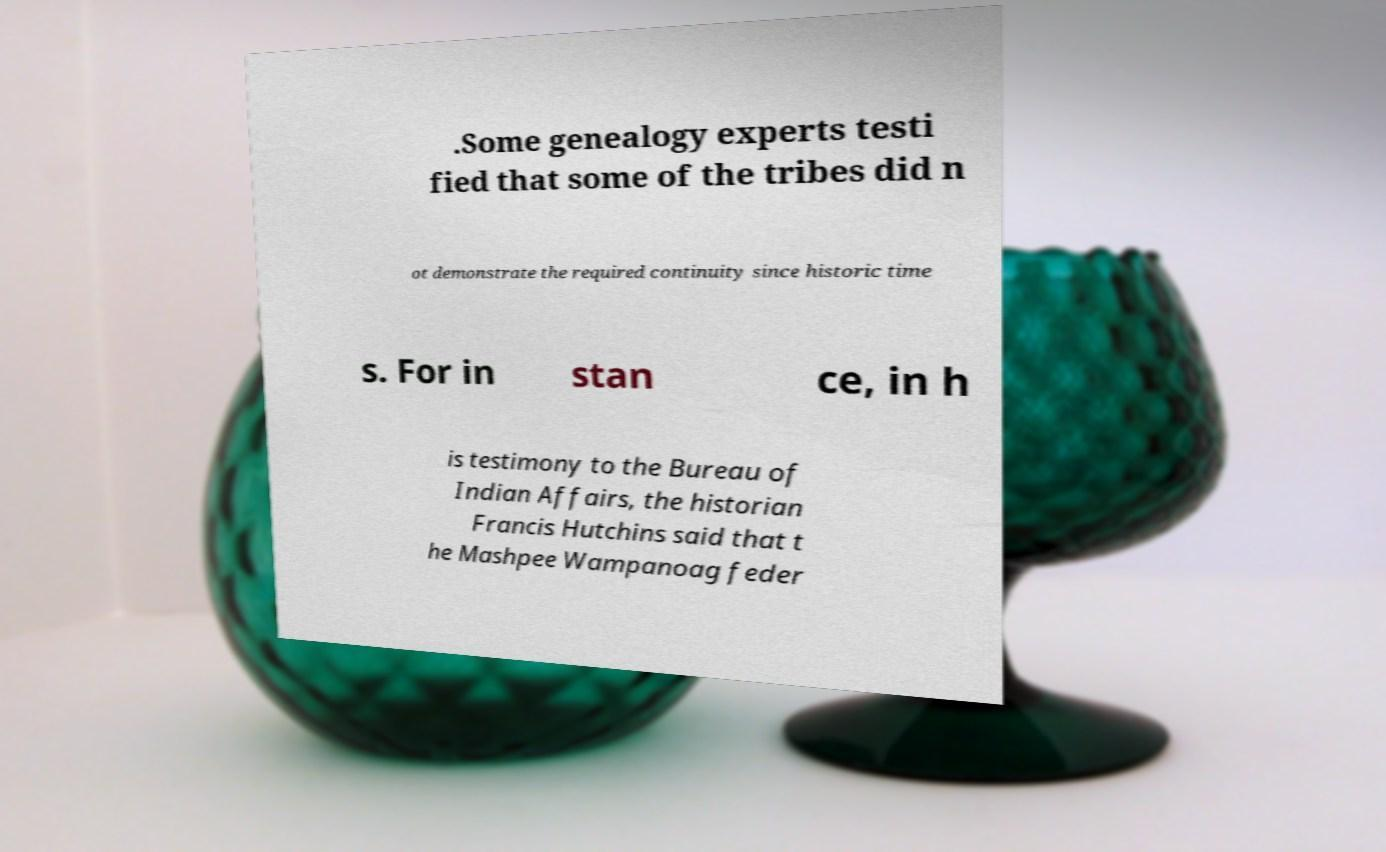There's text embedded in this image that I need extracted. Can you transcribe it verbatim? .Some genealogy experts testi fied that some of the tribes did n ot demonstrate the required continuity since historic time s. For in stan ce, in h is testimony to the Bureau of Indian Affairs, the historian Francis Hutchins said that t he Mashpee Wampanoag feder 